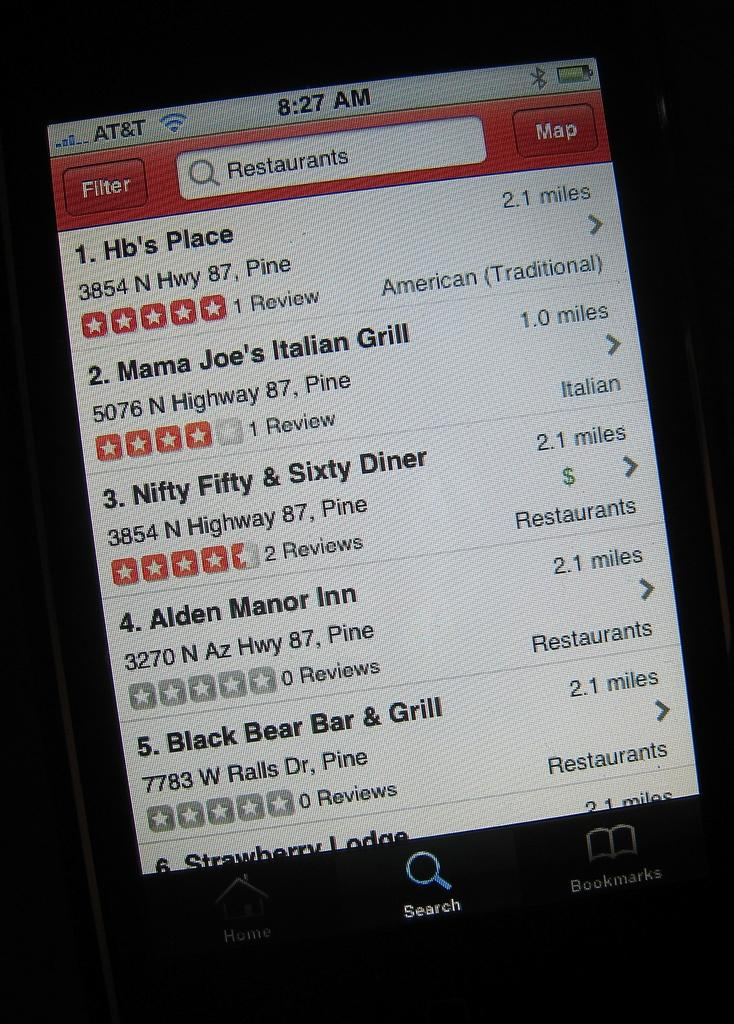<image>
Provide a brief description of the given image. The smartphone gets its service from AT&T while showing restaurant sites nearby. 